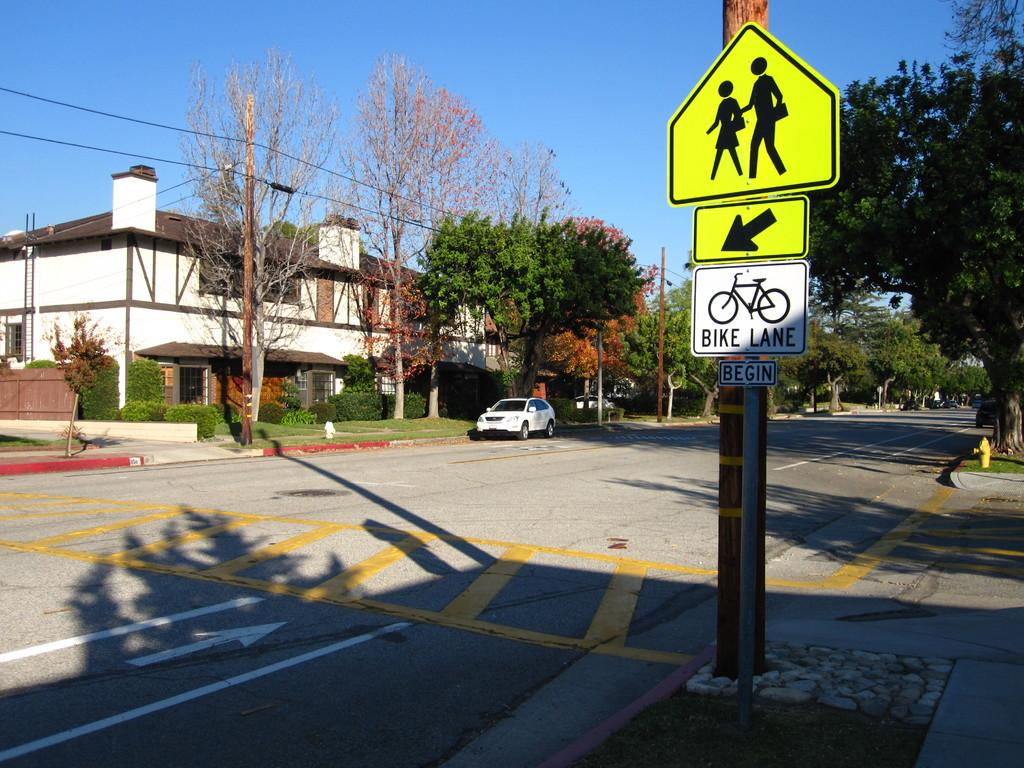<image>
Summarize the visual content of the image. A street in Fall where the Bike lane begins. 